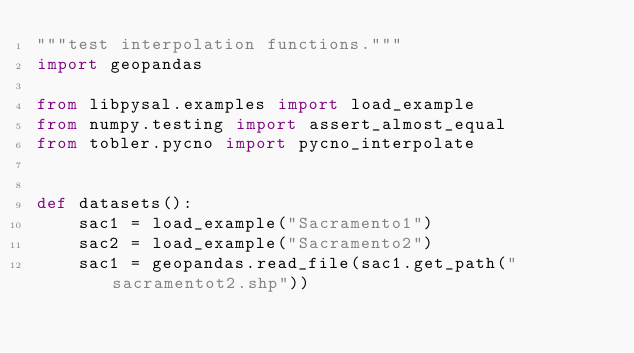<code> <loc_0><loc_0><loc_500><loc_500><_Python_>"""test interpolation functions."""
import geopandas

from libpysal.examples import load_example
from numpy.testing import assert_almost_equal
from tobler.pycno import pycno_interpolate


def datasets():
    sac1 = load_example("Sacramento1")
    sac2 = load_example("Sacramento2")
    sac1 = geopandas.read_file(sac1.get_path("sacramentot2.shp"))</code> 